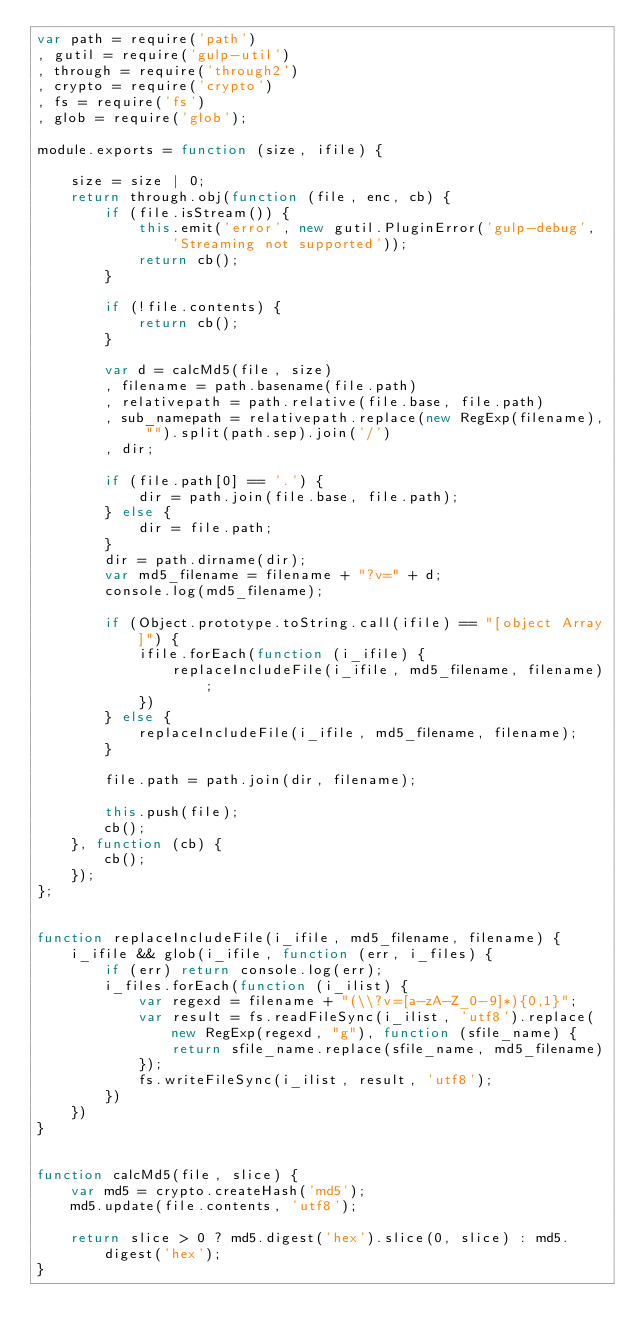<code> <loc_0><loc_0><loc_500><loc_500><_JavaScript_>var path = require('path')
, gutil = require('gulp-util')
, through = require('through2')
, crypto = require('crypto')
, fs = require('fs')
, glob = require('glob');

module.exports = function (size, ifile) {

    size = size | 0;
    return through.obj(function (file, enc, cb) {
        if (file.isStream()) {
            this.emit('error', new gutil.PluginError('gulp-debug', 'Streaming not supported'));
            return cb();
        }

        if (!file.contents) {
            return cb();
        }

        var d = calcMd5(file, size)
        , filename = path.basename(file.path)
        , relativepath = path.relative(file.base, file.path)
        , sub_namepath = relativepath.replace(new RegExp(filename), "").split(path.sep).join('/')
        , dir;

        if (file.path[0] == '.') {
            dir = path.join(file.base, file.path);
        } else {
            dir = file.path;
        }
        dir = path.dirname(dir);        
        var md5_filename = filename + "?v=" + d;
        console.log(md5_filename);

        if (Object.prototype.toString.call(ifile) == "[object Array]") {
            ifile.forEach(function (i_ifile) {
                replaceIncludeFile(i_ifile, md5_filename, filename);                
            })
        } else {
            replaceIncludeFile(i_ifile, md5_filename, filename);            
        }

        file.path = path.join(dir, filename);

        this.push(file);
        cb();
    }, function (cb) {
        cb();
    });
};


function replaceIncludeFile(i_ifile, md5_filename, filename) {
    i_ifile && glob(i_ifile, function (err, i_files) {
        if (err) return console.log(err);
        i_files.forEach(function (i_ilist) {
            var regexd = filename + "(\\?v=[a-zA-Z_0-9]*){0,1}";
            var result = fs.readFileSync(i_ilist, 'utf8').replace(new RegExp(regexd, "g"), function (sfile_name) {
                return sfile_name.replace(sfile_name, md5_filename)
            });
            fs.writeFileSync(i_ilist, result, 'utf8');
        })
    })
}


function calcMd5(file, slice) {
    var md5 = crypto.createHash('md5');
    md5.update(file.contents, 'utf8');

    return slice > 0 ? md5.digest('hex').slice(0, slice) : md5.digest('hex');
}
</code> 